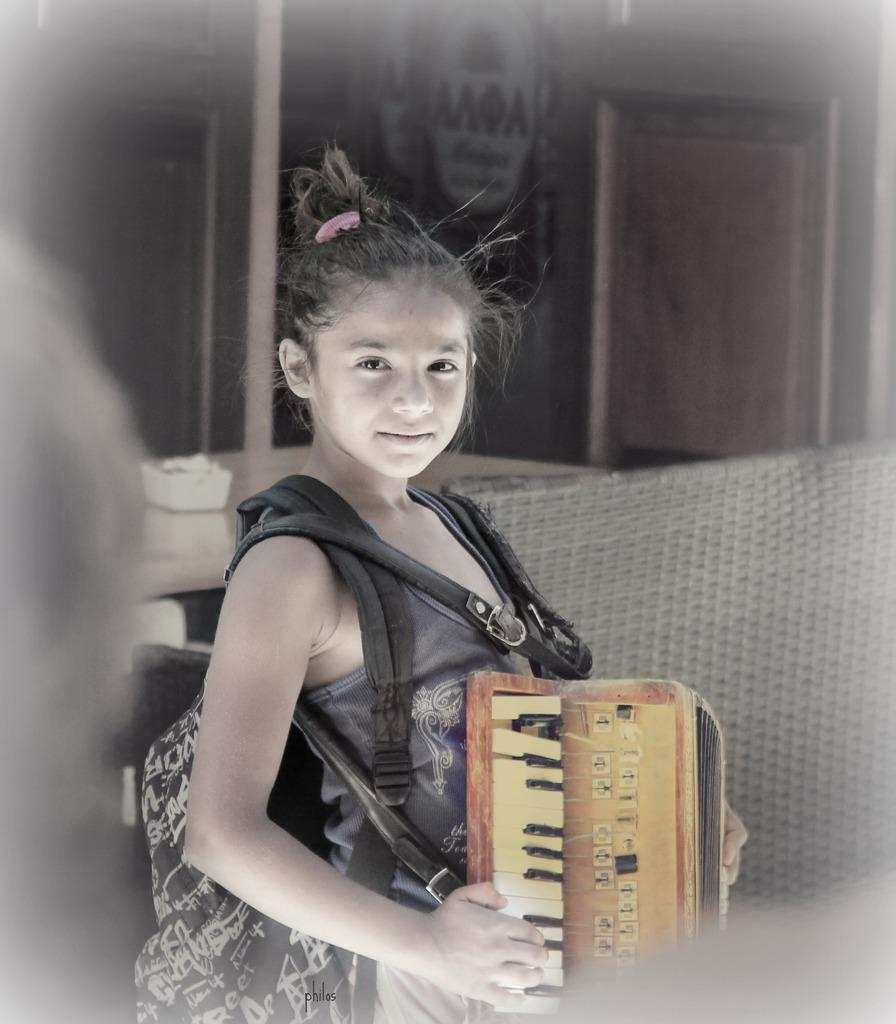What is the person in the image holding? The person is holding a musical instrument in the image. Can you describe the person's attire? The person is wearing a bag. What can be seen in the background of the image? There is a table and a door in the background of the image. What type of creature is playing the musical instrument in the image? There is no creature present in the image; it is a person holding and playing the musical instrument. 